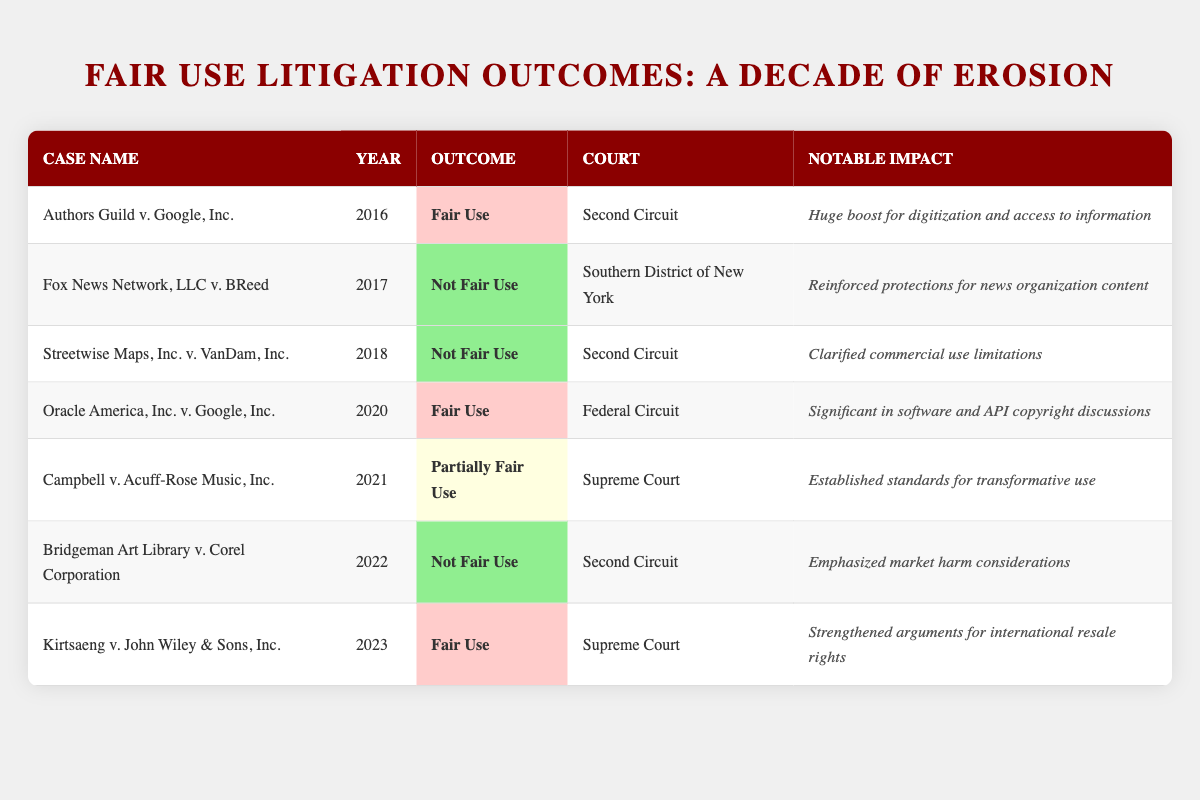What is the outcome of the case "Fox News Network, LLC v. BReed"? The outcome of the case "Fox News Network, LLC v. BReed" is found in the table under the "Outcome" column. The table states that it is "Not Fair Use."
Answer: Not Fair Use Which court heard the case "Kirtsaeng v. John Wiley & Sons, Inc."? To answer, look at the row for "Kirtsaeng v. John Wiley & Sons, Inc." and find the corresponding court in the "Court" column, which indicates it was the "Supreme Court."
Answer: Supreme Court In which year was the case "Bridgeman Art Library v. Corel Corporation" decided? The year can be found in the table under the "Year" column for the "Bridgeman Art Library v. Corel Corporation" case, which shows the year as 2022.
Answer: 2022 How many cases resulted in a "Not Fair Use" outcome? Count the instances in the "Outcome" column where it says "Not Fair Use." There are 4 cases listed: "Fox News Network, LLC v. BReed," "Streetwise Maps, Inc. v. VanDam, Inc.," "Bridgeman Art Library v. Corel Corporation." Thus, the total is 4.
Answer: 4 What notable impact was mentioned for the case "Oracle America, Inc. v. Google, Inc."? To find the answer, check the "Notable Impact" column for the corresponding row of "Oracle America, Inc. v. Google, Inc." It states the impact was significant in software and API copyright discussions.
Answer: Significant in software and API copyright discussions Which case resulted in a "Partially Fair Use" outcome? Refer to the table and look for the outcome that indicates "Partially Fair Use." This outcome is found in the row for "Campbell v. Acuff-Rose Music, Inc."
Answer: Campbell v. Acuff-Rose Music, Inc Was there any case decided in 2019? To determine this, review the "Year" column for all listed cases. There is no entry for 2019 in the table.
Answer: No Which court had the highest number of "Not Fair Use" outcomes? The easiest way to assess this is to look at the courts associated with each "Not Fair Use" outcome. The "Second Circuit" has three cases: "Streetwise Maps, Inc. v. VanDam, Inc.," "Bridgeman Art Library v. Corel Corporation," and "Authors Guild v. Google, Inc." No other court has more than one "Not Fair Use" case. Therefore, the "Second Circuit" is the answer.
Answer: Second Circuit What was the notable impact of the case "Kirtsaeng v. John Wiley & Sons, Inc."? Look at the "Notable Impact" column for "Kirtsaeng v. John Wiley & Sons, Inc." It indicates that the case strengthened arguments for international resale rights.
Answer: Strengthened arguments for international resale rights How many cases were decided by the Supreme Court? Count the cases listed under the "Court" column which specify "Supreme Court." There are 3 cases: "Campbell v. Acuff-Rose Music, Inc." and "Kirtsaeng v. John Wiley & Sons, Inc." Therefore, the total is 3.
Answer: 3 Which case had the notable impact of "Emphasized market harm considerations"? To find the answer, check the "Notable Impact" column for each case until the phrase is located. This impact is associated with the case "Bridgeman Art Library v. Corel Corporation."
Answer: Bridgeman Art Library v. Corel Corporation 